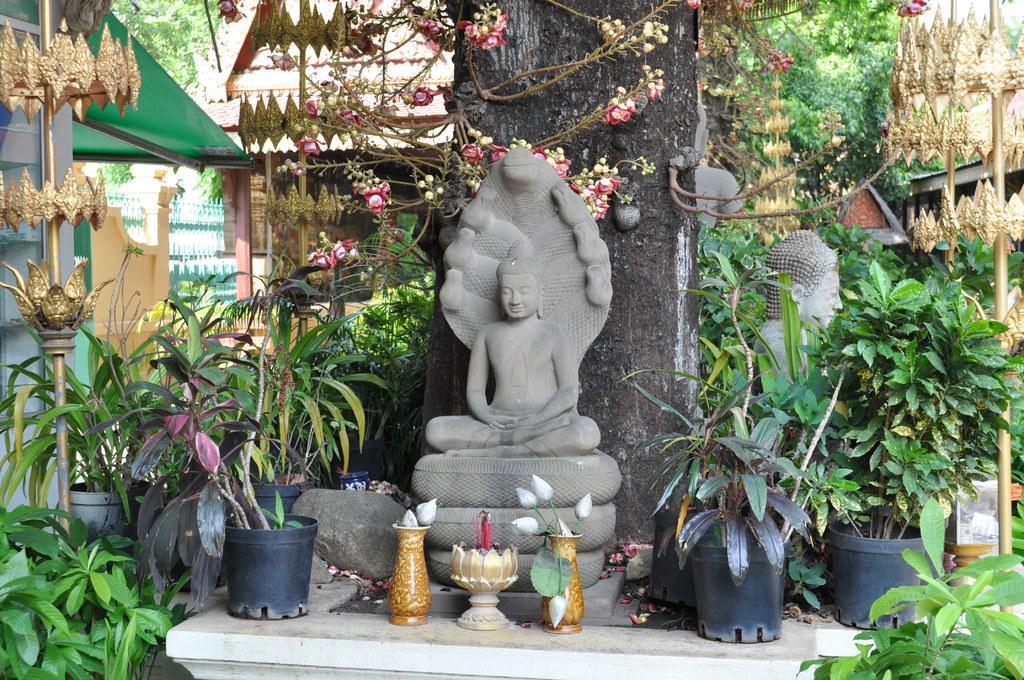Please provide a concise description of this image. In the picture we can see a tree near it we can see some Buddha statues and plants around the tree and behind the tree we can see a house with pillars to it and beside the house we can see a railing wall and behind it we can see a tree. 